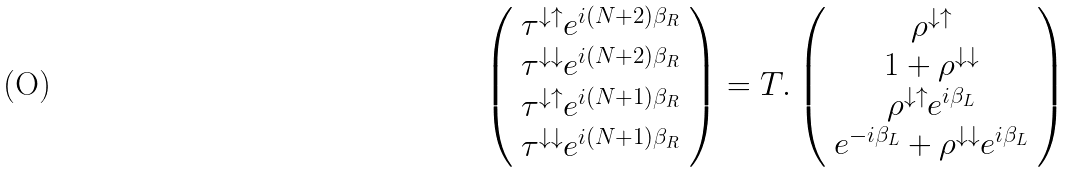Convert formula to latex. <formula><loc_0><loc_0><loc_500><loc_500>\left ( \begin{array} { c } \tau ^ { \downarrow \uparrow } e ^ { i ( N + 2 ) \beta _ { R } } \\ \tau ^ { \downarrow \downarrow } e ^ { i ( N + 2 ) \beta _ { R } } \\ \tau ^ { \downarrow \uparrow } e ^ { i ( N + 1 ) \beta _ { R } } \\ \tau ^ { \downarrow \downarrow } e ^ { i ( N + 1 ) \beta _ { R } } \end{array} \right ) = T . \left ( \begin{array} { c } \rho ^ { \downarrow \uparrow } \\ 1 + \rho ^ { \downarrow \downarrow } \\ \rho ^ { \downarrow \uparrow } e ^ { i \beta _ { L } } \\ e ^ { - i \beta _ { L } } + \rho ^ { \downarrow \downarrow } e ^ { i \beta _ { L } } \end{array} \right )</formula> 